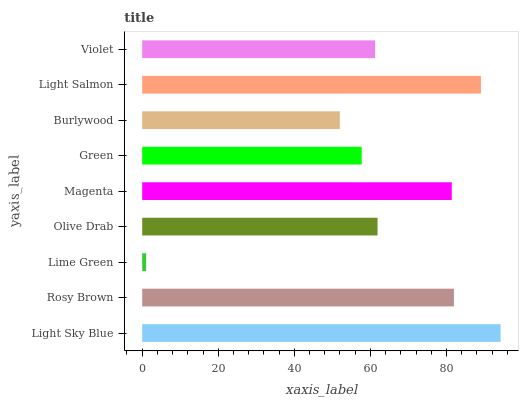Is Lime Green the minimum?
Answer yes or no. Yes. Is Light Sky Blue the maximum?
Answer yes or no. Yes. Is Rosy Brown the minimum?
Answer yes or no. No. Is Rosy Brown the maximum?
Answer yes or no. No. Is Light Sky Blue greater than Rosy Brown?
Answer yes or no. Yes. Is Rosy Brown less than Light Sky Blue?
Answer yes or no. Yes. Is Rosy Brown greater than Light Sky Blue?
Answer yes or no. No. Is Light Sky Blue less than Rosy Brown?
Answer yes or no. No. Is Olive Drab the high median?
Answer yes or no. Yes. Is Olive Drab the low median?
Answer yes or no. Yes. Is Burlywood the high median?
Answer yes or no. No. Is Violet the low median?
Answer yes or no. No. 